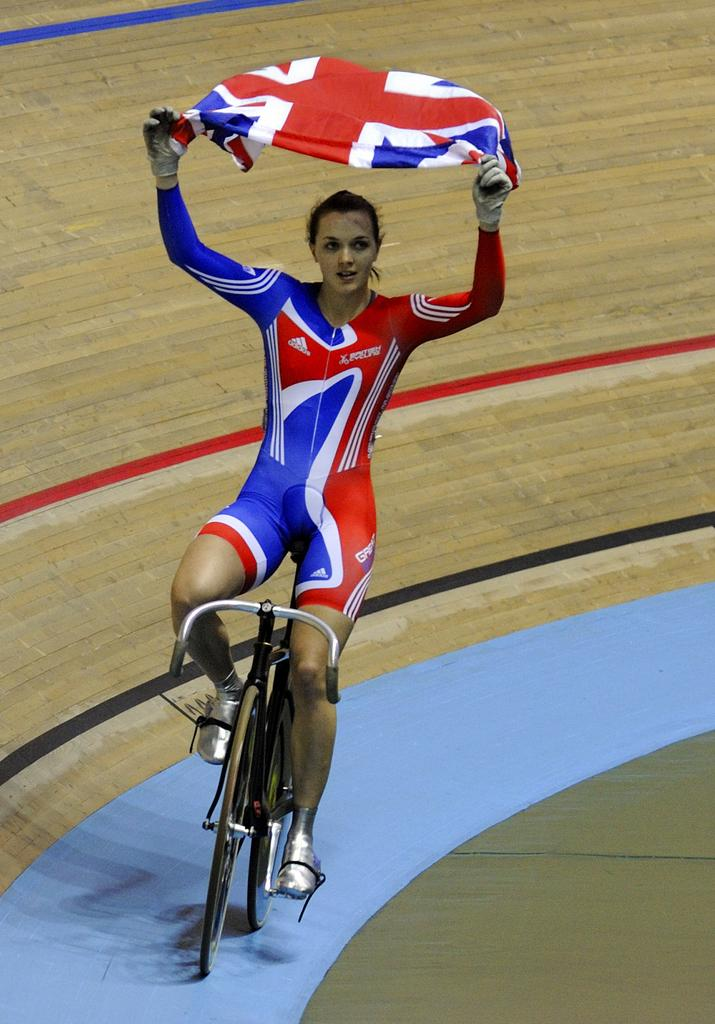What is the person in the image doing? The person is riding a bicycle in the image. What is the person wearing while riding the bicycle? The person is wearing a dress with red and blue colors. What is the person holding while riding the bicycle? The person is holding a flag. What can be seen in the background of the image? There is a board visible in the background of the image. Does the person have a pet with them while riding the bicycle? There is no pet visible in the image. How many achievements can be seen on the person's pocket in the image? The person is not wearing any pockets in the image, and therefore no achievements can be seen. 